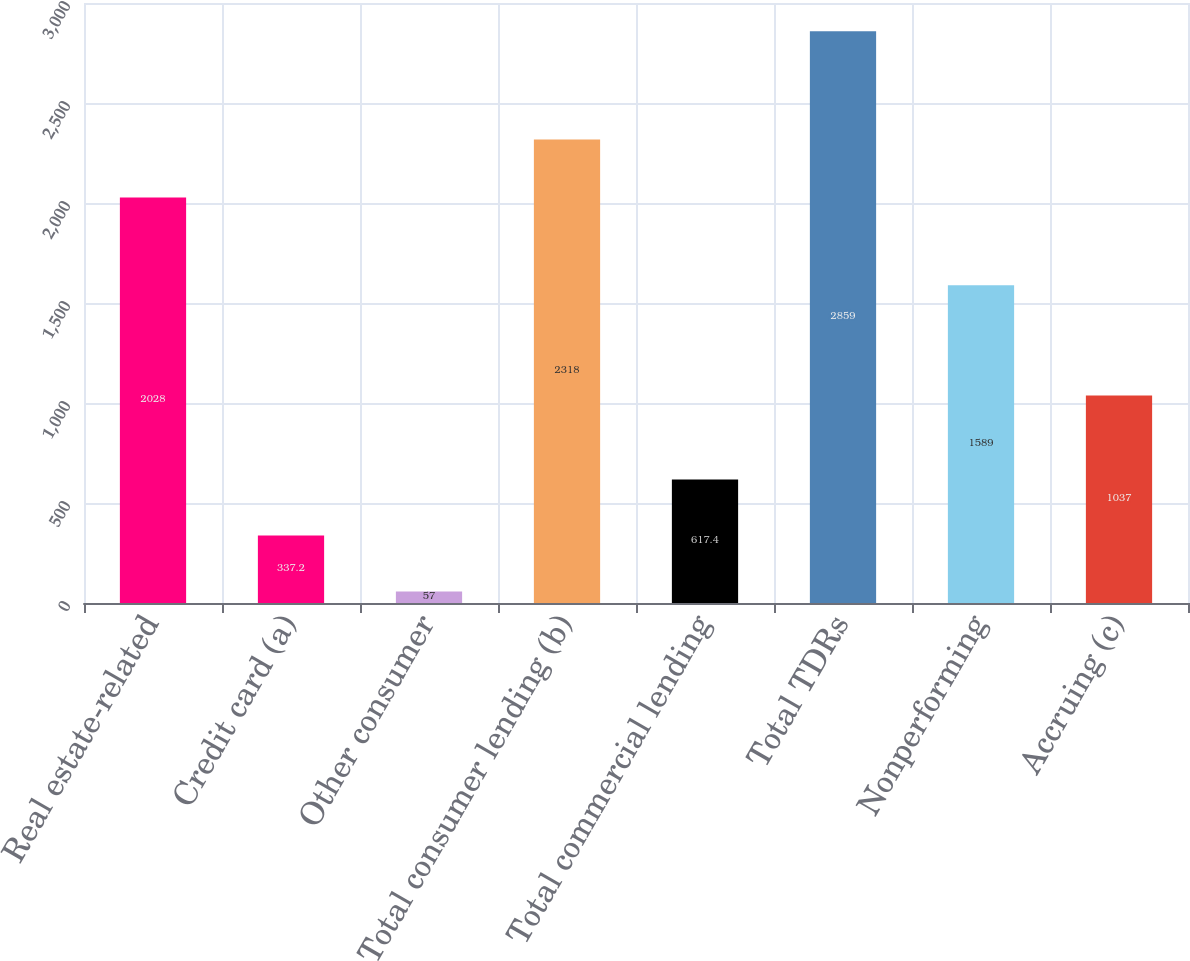<chart> <loc_0><loc_0><loc_500><loc_500><bar_chart><fcel>Real estate-related<fcel>Credit card (a)<fcel>Other consumer<fcel>Total consumer lending (b)<fcel>Total commercial lending<fcel>Total TDRs<fcel>Nonperforming<fcel>Accruing (c)<nl><fcel>2028<fcel>337.2<fcel>57<fcel>2318<fcel>617.4<fcel>2859<fcel>1589<fcel>1037<nl></chart> 